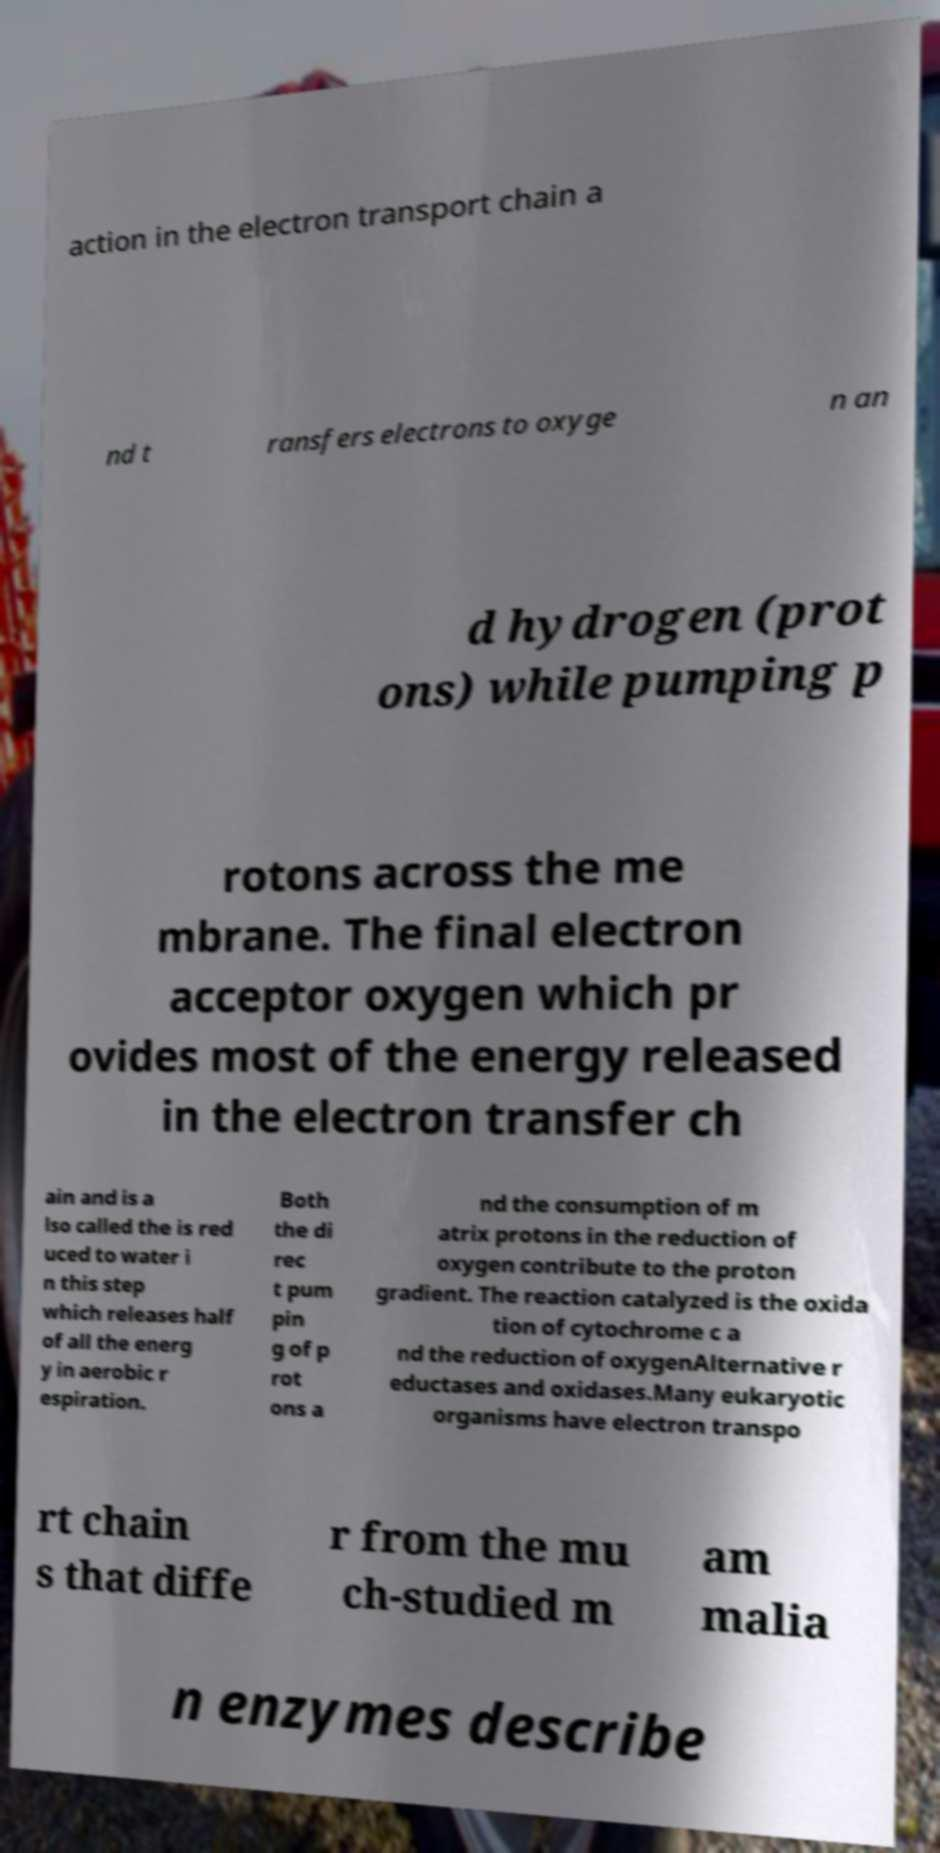For documentation purposes, I need the text within this image transcribed. Could you provide that? action in the electron transport chain a nd t ransfers electrons to oxyge n an d hydrogen (prot ons) while pumping p rotons across the me mbrane. The final electron acceptor oxygen which pr ovides most of the energy released in the electron transfer ch ain and is a lso called the is red uced to water i n this step which releases half of all the energ y in aerobic r espiration. Both the di rec t pum pin g of p rot ons a nd the consumption of m atrix protons in the reduction of oxygen contribute to the proton gradient. The reaction catalyzed is the oxida tion of cytochrome c a nd the reduction of oxygenAlternative r eductases and oxidases.Many eukaryotic organisms have electron transpo rt chain s that diffe r from the mu ch-studied m am malia n enzymes describe 